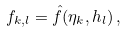Convert formula to latex. <formula><loc_0><loc_0><loc_500><loc_500>f _ { k , l } = \hat { f } ( \eta _ { k } , h _ { l } ) \, ,</formula> 